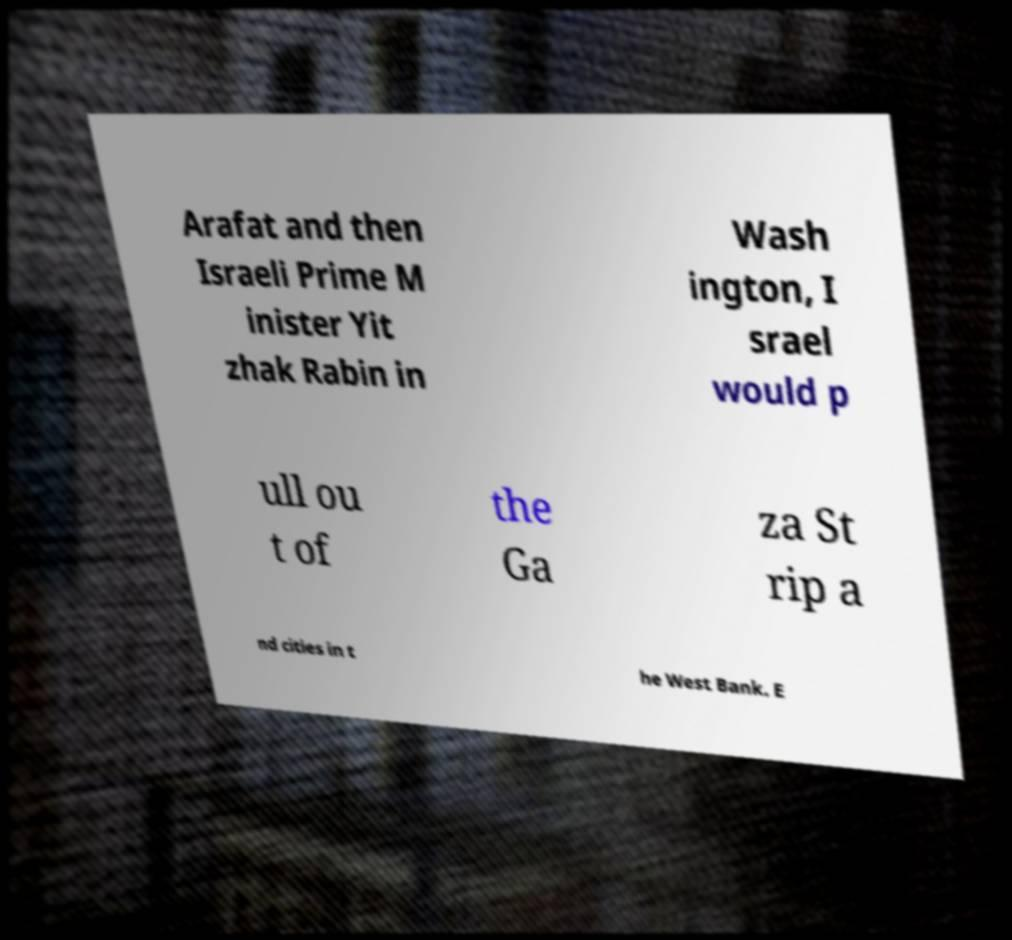I need the written content from this picture converted into text. Can you do that? Arafat and then Israeli Prime M inister Yit zhak Rabin in Wash ington, I srael would p ull ou t of the Ga za St rip a nd cities in t he West Bank. E 